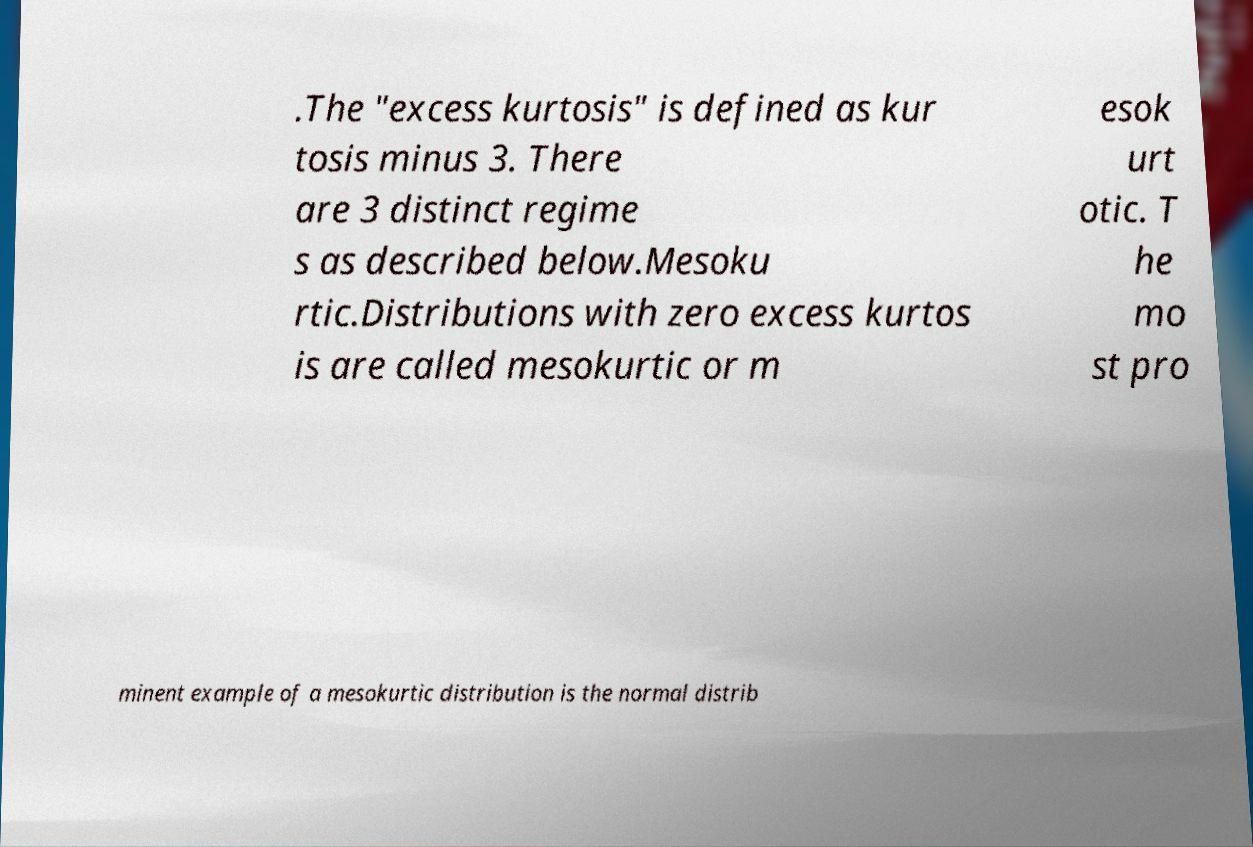Could you extract and type out the text from this image? .The "excess kurtosis" is defined as kur tosis minus 3. There are 3 distinct regime s as described below.Mesoku rtic.Distributions with zero excess kurtos is are called mesokurtic or m esok urt otic. T he mo st pro minent example of a mesokurtic distribution is the normal distrib 